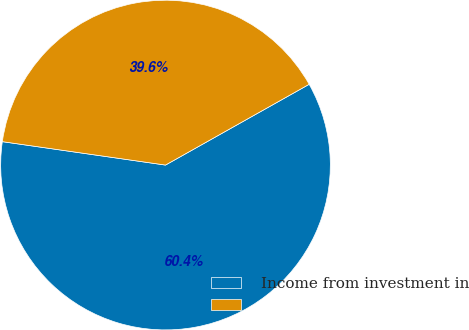Convert chart. <chart><loc_0><loc_0><loc_500><loc_500><pie_chart><fcel>Income from investment in<fcel>Unnamed: 1<nl><fcel>60.42%<fcel>39.58%<nl></chart> 